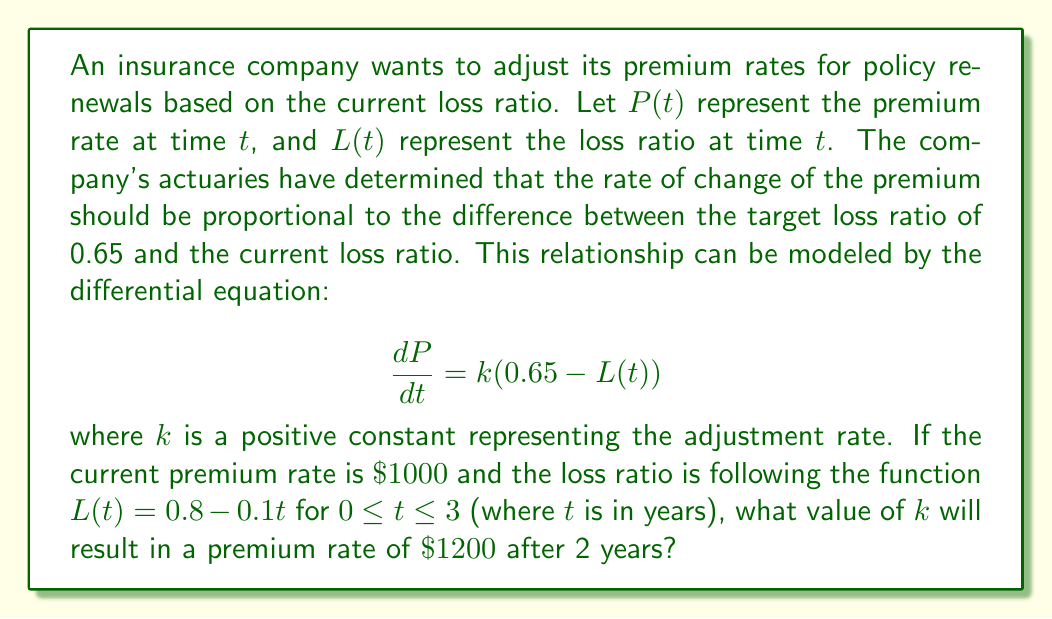Show me your answer to this math problem. To solve this problem, we need to follow these steps:

1) First, we need to solve the differential equation. We have:

   $$\frac{dP}{dt} = k(0.65 - L(t))$$
   $$\frac{dP}{dt} = k(0.65 - (0.8 - 0.1t))$$
   $$\frac{dP}{dt} = k(-0.15 + 0.1t)$$

2) Integrating both sides:

   $$P = k(-0.15t + 0.05t^2) + C$$

3) We know that at $t=0$, $P=1000$, so we can find $C$:

   $1000 = k(0) + C$
   $C = 1000$

4) Therefore, our general solution is:

   $$P(t) = k(-0.15t + 0.05t^2) + 1000$$

5) We want $P(2) = 1200$, so:

   $$1200 = k(-0.15(2) + 0.05(2^2)) + 1000$$
   $$1200 = k(-0.3 + 0.2) + 1000$$
   $$1200 = -0.1k + 1000$$
   $$200 = -0.1k$$
   $$k = -2000$$

6) However, we're told that $k$ is positive, so we need to take the absolute value:

   $$k = 2000$$

Therefore, the value of $k$ that will result in a premium rate of $\$1200$ after 2 years is 2000.
Answer: $k = 2000$ 